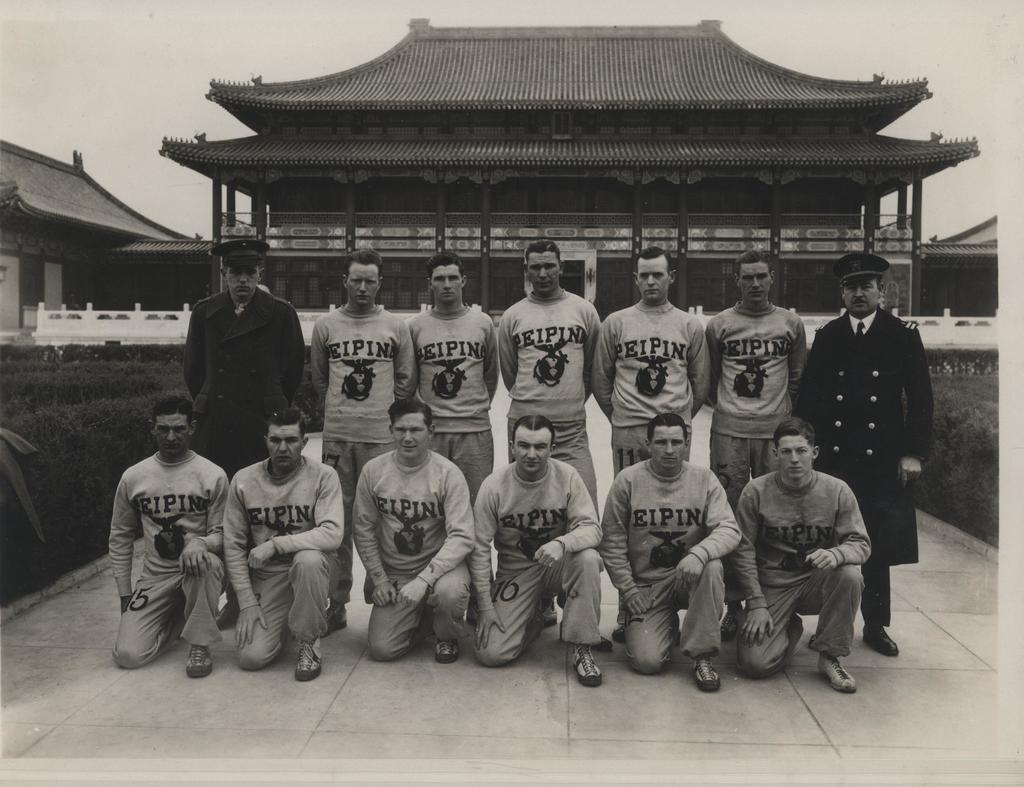Provide a one-sentence caption for the provided image. Team getting their picture taken in Japan, their jerseys say PeiPin. 